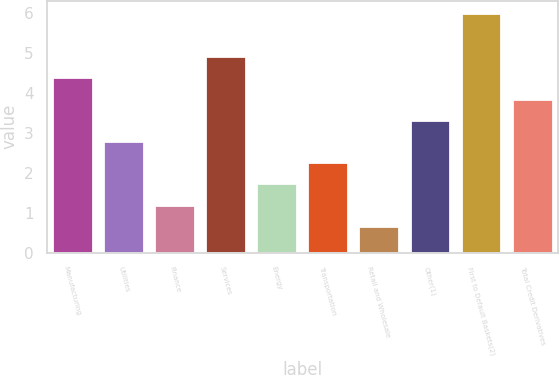Convert chart to OTSL. <chart><loc_0><loc_0><loc_500><loc_500><bar_chart><fcel>Manufacturing<fcel>Utilities<fcel>Finance<fcel>Services<fcel>Energy<fcel>Transportation<fcel>Retail and Wholesale<fcel>Other(1)<fcel>First to Default Baskets(2)<fcel>Total Credit Derivatives<nl><fcel>4.38<fcel>2.79<fcel>1.2<fcel>4.91<fcel>1.73<fcel>2.26<fcel>0.67<fcel>3.32<fcel>6<fcel>3.85<nl></chart> 